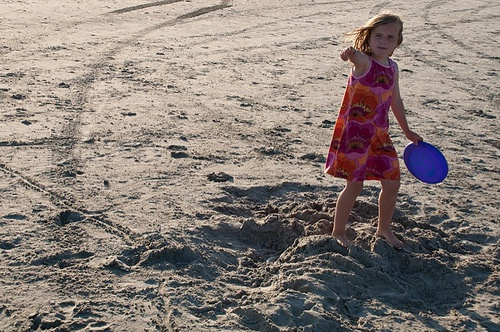Describe the objects in this image and their specific colors. I can see people in lightgray, maroon, brown, purple, and black tones and frisbee in lightgray, darkblue, navy, darkgray, and gray tones in this image. 